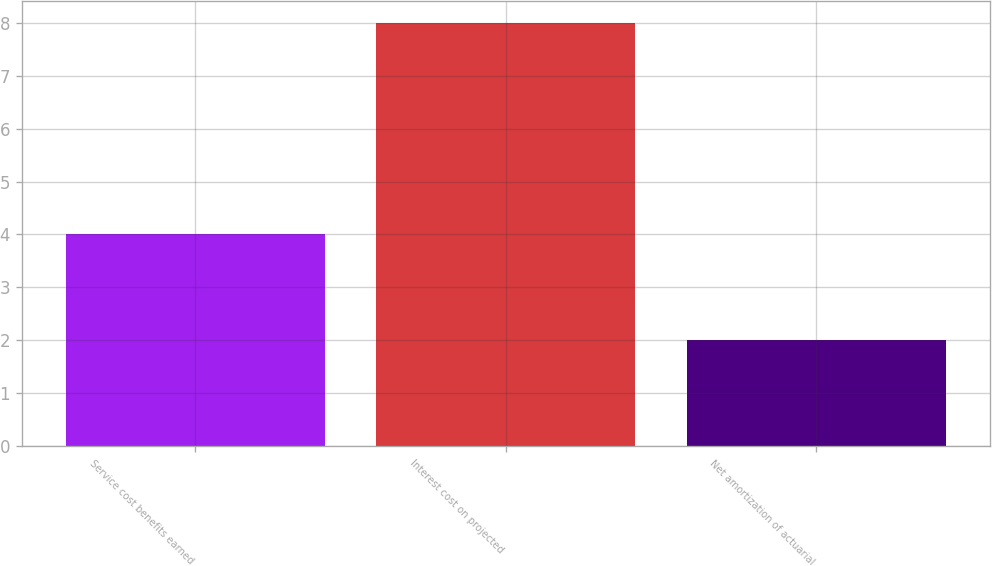Convert chart to OTSL. <chart><loc_0><loc_0><loc_500><loc_500><bar_chart><fcel>Service cost benefits earned<fcel>Interest cost on projected<fcel>Net amortization of actuarial<nl><fcel>4<fcel>8<fcel>2<nl></chart> 